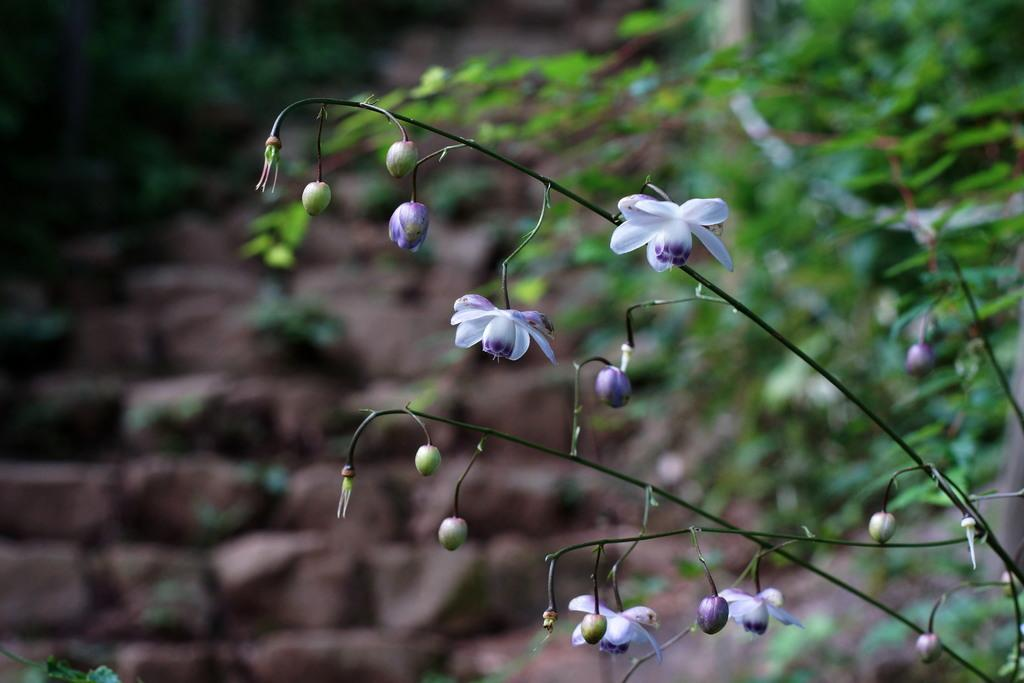What colors are the flowers in the image? The flowers in the image are in white and purple colors. What can be seen in the background of the image? There are plants in green color in the background of the image. What type of structure is present in the image? There are stairs in brown color in the image. What type of pen is being used to write on the gravestone in the image? There is no pen or gravestone present in the image; it features flowers, plants, and stairs. 